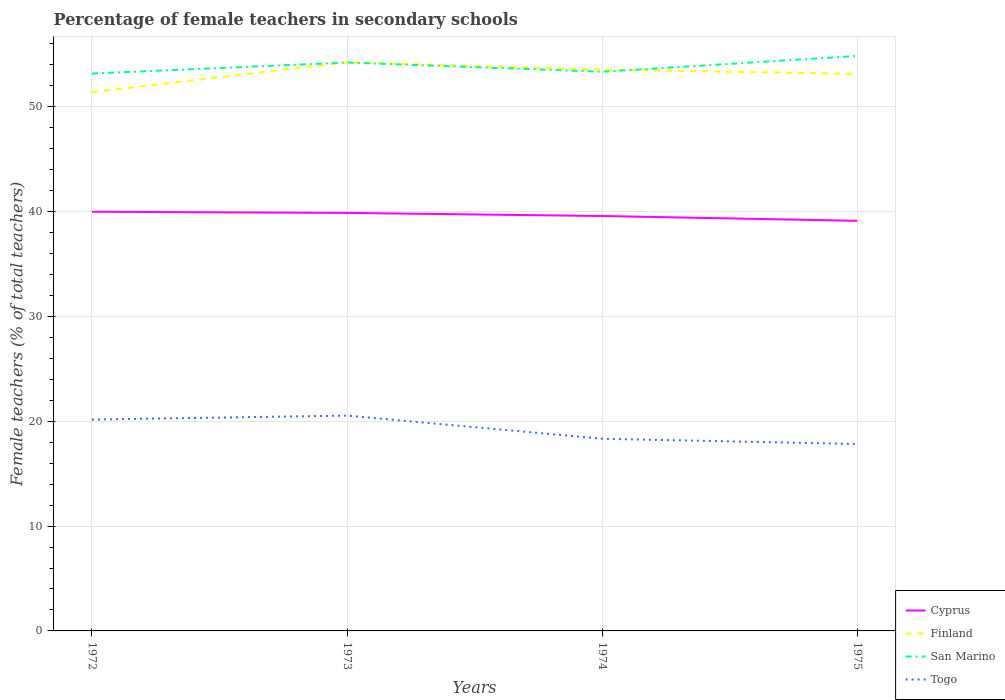How many different coloured lines are there?
Keep it short and to the point. 4. Does the line corresponding to Cyprus intersect with the line corresponding to Togo?
Your response must be concise. No. Is the number of lines equal to the number of legend labels?
Ensure brevity in your answer.  Yes. Across all years, what is the maximum percentage of female teachers in San Marino?
Offer a terse response. 53.16. In which year was the percentage of female teachers in Cyprus maximum?
Your answer should be compact. 1975. What is the total percentage of female teachers in Finland in the graph?
Your answer should be compact. -1.73. What is the difference between the highest and the second highest percentage of female teachers in Cyprus?
Offer a very short reply. 0.86. Is the percentage of female teachers in Cyprus strictly greater than the percentage of female teachers in Finland over the years?
Make the answer very short. Yes. What is the difference between two consecutive major ticks on the Y-axis?
Keep it short and to the point. 10. Are the values on the major ticks of Y-axis written in scientific E-notation?
Offer a very short reply. No. What is the title of the graph?
Your answer should be compact. Percentage of female teachers in secondary schools. Does "Eritrea" appear as one of the legend labels in the graph?
Offer a terse response. No. What is the label or title of the Y-axis?
Make the answer very short. Female teachers (% of total teachers). What is the Female teachers (% of total teachers) in Cyprus in 1972?
Give a very brief answer. 39.98. What is the Female teachers (% of total teachers) of Finland in 1972?
Make the answer very short. 51.4. What is the Female teachers (% of total teachers) in San Marino in 1972?
Your answer should be very brief. 53.16. What is the Female teachers (% of total teachers) of Togo in 1972?
Ensure brevity in your answer.  20.16. What is the Female teachers (% of total teachers) in Cyprus in 1973?
Offer a terse response. 39.87. What is the Female teachers (% of total teachers) in Finland in 1973?
Ensure brevity in your answer.  54.23. What is the Female teachers (% of total teachers) in San Marino in 1973?
Your answer should be very brief. 54.22. What is the Female teachers (% of total teachers) in Togo in 1973?
Your answer should be very brief. 20.54. What is the Female teachers (% of total teachers) in Cyprus in 1974?
Provide a short and direct response. 39.58. What is the Female teachers (% of total teachers) of Finland in 1974?
Provide a short and direct response. 53.55. What is the Female teachers (% of total teachers) in San Marino in 1974?
Your response must be concise. 53.33. What is the Female teachers (% of total teachers) of Togo in 1974?
Provide a short and direct response. 18.33. What is the Female teachers (% of total teachers) in Cyprus in 1975?
Make the answer very short. 39.12. What is the Female teachers (% of total teachers) in Finland in 1975?
Your answer should be compact. 53.13. What is the Female teachers (% of total teachers) in San Marino in 1975?
Keep it short and to the point. 54.84. What is the Female teachers (% of total teachers) in Togo in 1975?
Your answer should be very brief. 17.83. Across all years, what is the maximum Female teachers (% of total teachers) of Cyprus?
Ensure brevity in your answer.  39.98. Across all years, what is the maximum Female teachers (% of total teachers) in Finland?
Offer a very short reply. 54.23. Across all years, what is the maximum Female teachers (% of total teachers) in San Marino?
Your response must be concise. 54.84. Across all years, what is the maximum Female teachers (% of total teachers) of Togo?
Offer a terse response. 20.54. Across all years, what is the minimum Female teachers (% of total teachers) of Cyprus?
Offer a terse response. 39.12. Across all years, what is the minimum Female teachers (% of total teachers) in Finland?
Your response must be concise. 51.4. Across all years, what is the minimum Female teachers (% of total teachers) of San Marino?
Provide a succinct answer. 53.16. Across all years, what is the minimum Female teachers (% of total teachers) in Togo?
Offer a terse response. 17.83. What is the total Female teachers (% of total teachers) in Cyprus in the graph?
Your response must be concise. 158.54. What is the total Female teachers (% of total teachers) in Finland in the graph?
Your answer should be compact. 212.31. What is the total Female teachers (% of total teachers) of San Marino in the graph?
Make the answer very short. 215.55. What is the total Female teachers (% of total teachers) of Togo in the graph?
Ensure brevity in your answer.  76.86. What is the difference between the Female teachers (% of total teachers) in Cyprus in 1972 and that in 1973?
Make the answer very short. 0.11. What is the difference between the Female teachers (% of total teachers) in Finland in 1972 and that in 1973?
Provide a short and direct response. -2.84. What is the difference between the Female teachers (% of total teachers) in San Marino in 1972 and that in 1973?
Make the answer very short. -1.05. What is the difference between the Female teachers (% of total teachers) in Togo in 1972 and that in 1973?
Ensure brevity in your answer.  -0.38. What is the difference between the Female teachers (% of total teachers) of Cyprus in 1972 and that in 1974?
Offer a terse response. 0.41. What is the difference between the Female teachers (% of total teachers) in Finland in 1972 and that in 1974?
Your response must be concise. -2.15. What is the difference between the Female teachers (% of total teachers) of San Marino in 1972 and that in 1974?
Your answer should be compact. -0.17. What is the difference between the Female teachers (% of total teachers) of Togo in 1972 and that in 1974?
Keep it short and to the point. 1.83. What is the difference between the Female teachers (% of total teachers) in Cyprus in 1972 and that in 1975?
Provide a succinct answer. 0.86. What is the difference between the Female teachers (% of total teachers) of Finland in 1972 and that in 1975?
Give a very brief answer. -1.73. What is the difference between the Female teachers (% of total teachers) of San Marino in 1972 and that in 1975?
Keep it short and to the point. -1.67. What is the difference between the Female teachers (% of total teachers) of Togo in 1972 and that in 1975?
Keep it short and to the point. 2.33. What is the difference between the Female teachers (% of total teachers) of Cyprus in 1973 and that in 1974?
Make the answer very short. 0.3. What is the difference between the Female teachers (% of total teachers) of Finland in 1973 and that in 1974?
Offer a very short reply. 0.69. What is the difference between the Female teachers (% of total teachers) of San Marino in 1973 and that in 1974?
Provide a short and direct response. 0.88. What is the difference between the Female teachers (% of total teachers) of Togo in 1973 and that in 1974?
Keep it short and to the point. 2.21. What is the difference between the Female teachers (% of total teachers) of Cyprus in 1973 and that in 1975?
Offer a very short reply. 0.75. What is the difference between the Female teachers (% of total teachers) of Finland in 1973 and that in 1975?
Your answer should be very brief. 1.1. What is the difference between the Female teachers (% of total teachers) in San Marino in 1973 and that in 1975?
Your answer should be compact. -0.62. What is the difference between the Female teachers (% of total teachers) of Togo in 1973 and that in 1975?
Offer a very short reply. 2.71. What is the difference between the Female teachers (% of total teachers) in Cyprus in 1974 and that in 1975?
Provide a short and direct response. 0.46. What is the difference between the Female teachers (% of total teachers) of Finland in 1974 and that in 1975?
Offer a very short reply. 0.42. What is the difference between the Female teachers (% of total teachers) of San Marino in 1974 and that in 1975?
Your response must be concise. -1.51. What is the difference between the Female teachers (% of total teachers) of Togo in 1974 and that in 1975?
Provide a short and direct response. 0.5. What is the difference between the Female teachers (% of total teachers) in Cyprus in 1972 and the Female teachers (% of total teachers) in Finland in 1973?
Provide a short and direct response. -14.25. What is the difference between the Female teachers (% of total teachers) of Cyprus in 1972 and the Female teachers (% of total teachers) of San Marino in 1973?
Keep it short and to the point. -14.24. What is the difference between the Female teachers (% of total teachers) of Cyprus in 1972 and the Female teachers (% of total teachers) of Togo in 1973?
Give a very brief answer. 19.44. What is the difference between the Female teachers (% of total teachers) in Finland in 1972 and the Female teachers (% of total teachers) in San Marino in 1973?
Offer a terse response. -2.82. What is the difference between the Female teachers (% of total teachers) in Finland in 1972 and the Female teachers (% of total teachers) in Togo in 1973?
Provide a short and direct response. 30.86. What is the difference between the Female teachers (% of total teachers) of San Marino in 1972 and the Female teachers (% of total teachers) of Togo in 1973?
Ensure brevity in your answer.  32.63. What is the difference between the Female teachers (% of total teachers) of Cyprus in 1972 and the Female teachers (% of total teachers) of Finland in 1974?
Make the answer very short. -13.57. What is the difference between the Female teachers (% of total teachers) in Cyprus in 1972 and the Female teachers (% of total teachers) in San Marino in 1974?
Offer a very short reply. -13.35. What is the difference between the Female teachers (% of total teachers) of Cyprus in 1972 and the Female teachers (% of total teachers) of Togo in 1974?
Your answer should be very brief. 21.65. What is the difference between the Female teachers (% of total teachers) of Finland in 1972 and the Female teachers (% of total teachers) of San Marino in 1974?
Provide a succinct answer. -1.94. What is the difference between the Female teachers (% of total teachers) in Finland in 1972 and the Female teachers (% of total teachers) in Togo in 1974?
Offer a terse response. 33.07. What is the difference between the Female teachers (% of total teachers) in San Marino in 1972 and the Female teachers (% of total teachers) in Togo in 1974?
Your response must be concise. 34.83. What is the difference between the Female teachers (% of total teachers) of Cyprus in 1972 and the Female teachers (% of total teachers) of Finland in 1975?
Offer a very short reply. -13.15. What is the difference between the Female teachers (% of total teachers) in Cyprus in 1972 and the Female teachers (% of total teachers) in San Marino in 1975?
Provide a succinct answer. -14.86. What is the difference between the Female teachers (% of total teachers) in Cyprus in 1972 and the Female teachers (% of total teachers) in Togo in 1975?
Your answer should be very brief. 22.15. What is the difference between the Female teachers (% of total teachers) of Finland in 1972 and the Female teachers (% of total teachers) of San Marino in 1975?
Offer a very short reply. -3.44. What is the difference between the Female teachers (% of total teachers) of Finland in 1972 and the Female teachers (% of total teachers) of Togo in 1975?
Provide a short and direct response. 33.57. What is the difference between the Female teachers (% of total teachers) of San Marino in 1972 and the Female teachers (% of total teachers) of Togo in 1975?
Make the answer very short. 35.34. What is the difference between the Female teachers (% of total teachers) in Cyprus in 1973 and the Female teachers (% of total teachers) in Finland in 1974?
Provide a short and direct response. -13.68. What is the difference between the Female teachers (% of total teachers) in Cyprus in 1973 and the Female teachers (% of total teachers) in San Marino in 1974?
Make the answer very short. -13.46. What is the difference between the Female teachers (% of total teachers) of Cyprus in 1973 and the Female teachers (% of total teachers) of Togo in 1974?
Keep it short and to the point. 21.54. What is the difference between the Female teachers (% of total teachers) in Finland in 1973 and the Female teachers (% of total teachers) in San Marino in 1974?
Your answer should be compact. 0.9. What is the difference between the Female teachers (% of total teachers) in Finland in 1973 and the Female teachers (% of total teachers) in Togo in 1974?
Your answer should be compact. 35.9. What is the difference between the Female teachers (% of total teachers) in San Marino in 1973 and the Female teachers (% of total teachers) in Togo in 1974?
Provide a short and direct response. 35.89. What is the difference between the Female teachers (% of total teachers) of Cyprus in 1973 and the Female teachers (% of total teachers) of Finland in 1975?
Give a very brief answer. -13.26. What is the difference between the Female teachers (% of total teachers) in Cyprus in 1973 and the Female teachers (% of total teachers) in San Marino in 1975?
Provide a short and direct response. -14.97. What is the difference between the Female teachers (% of total teachers) of Cyprus in 1973 and the Female teachers (% of total teachers) of Togo in 1975?
Ensure brevity in your answer.  22.04. What is the difference between the Female teachers (% of total teachers) of Finland in 1973 and the Female teachers (% of total teachers) of San Marino in 1975?
Your answer should be compact. -0.6. What is the difference between the Female teachers (% of total teachers) of Finland in 1973 and the Female teachers (% of total teachers) of Togo in 1975?
Offer a very short reply. 36.41. What is the difference between the Female teachers (% of total teachers) of San Marino in 1973 and the Female teachers (% of total teachers) of Togo in 1975?
Provide a succinct answer. 36.39. What is the difference between the Female teachers (% of total teachers) of Cyprus in 1974 and the Female teachers (% of total teachers) of Finland in 1975?
Provide a succinct answer. -13.55. What is the difference between the Female teachers (% of total teachers) of Cyprus in 1974 and the Female teachers (% of total teachers) of San Marino in 1975?
Provide a short and direct response. -15.26. What is the difference between the Female teachers (% of total teachers) in Cyprus in 1974 and the Female teachers (% of total teachers) in Togo in 1975?
Your answer should be compact. 21.75. What is the difference between the Female teachers (% of total teachers) of Finland in 1974 and the Female teachers (% of total teachers) of San Marino in 1975?
Your response must be concise. -1.29. What is the difference between the Female teachers (% of total teachers) of Finland in 1974 and the Female teachers (% of total teachers) of Togo in 1975?
Keep it short and to the point. 35.72. What is the difference between the Female teachers (% of total teachers) in San Marino in 1974 and the Female teachers (% of total teachers) in Togo in 1975?
Offer a very short reply. 35.51. What is the average Female teachers (% of total teachers) of Cyprus per year?
Keep it short and to the point. 39.64. What is the average Female teachers (% of total teachers) of Finland per year?
Give a very brief answer. 53.08. What is the average Female teachers (% of total teachers) in San Marino per year?
Provide a short and direct response. 53.89. What is the average Female teachers (% of total teachers) in Togo per year?
Your answer should be compact. 19.21. In the year 1972, what is the difference between the Female teachers (% of total teachers) of Cyprus and Female teachers (% of total teachers) of Finland?
Provide a succinct answer. -11.41. In the year 1972, what is the difference between the Female teachers (% of total teachers) in Cyprus and Female teachers (% of total teachers) in San Marino?
Make the answer very short. -13.18. In the year 1972, what is the difference between the Female teachers (% of total teachers) of Cyprus and Female teachers (% of total teachers) of Togo?
Ensure brevity in your answer.  19.82. In the year 1972, what is the difference between the Female teachers (% of total teachers) of Finland and Female teachers (% of total teachers) of San Marino?
Provide a short and direct response. -1.77. In the year 1972, what is the difference between the Female teachers (% of total teachers) in Finland and Female teachers (% of total teachers) in Togo?
Your answer should be very brief. 31.24. In the year 1972, what is the difference between the Female teachers (% of total teachers) in San Marino and Female teachers (% of total teachers) in Togo?
Provide a short and direct response. 33. In the year 1973, what is the difference between the Female teachers (% of total teachers) in Cyprus and Female teachers (% of total teachers) in Finland?
Give a very brief answer. -14.36. In the year 1973, what is the difference between the Female teachers (% of total teachers) in Cyprus and Female teachers (% of total teachers) in San Marino?
Keep it short and to the point. -14.35. In the year 1973, what is the difference between the Female teachers (% of total teachers) in Cyprus and Female teachers (% of total teachers) in Togo?
Provide a short and direct response. 19.33. In the year 1973, what is the difference between the Female teachers (% of total teachers) of Finland and Female teachers (% of total teachers) of San Marino?
Your response must be concise. 0.02. In the year 1973, what is the difference between the Female teachers (% of total teachers) of Finland and Female teachers (% of total teachers) of Togo?
Provide a succinct answer. 33.7. In the year 1973, what is the difference between the Female teachers (% of total teachers) in San Marino and Female teachers (% of total teachers) in Togo?
Your response must be concise. 33.68. In the year 1974, what is the difference between the Female teachers (% of total teachers) of Cyprus and Female teachers (% of total teachers) of Finland?
Your answer should be very brief. -13.97. In the year 1974, what is the difference between the Female teachers (% of total teachers) in Cyprus and Female teachers (% of total teachers) in San Marino?
Provide a succinct answer. -13.76. In the year 1974, what is the difference between the Female teachers (% of total teachers) in Cyprus and Female teachers (% of total teachers) in Togo?
Keep it short and to the point. 21.24. In the year 1974, what is the difference between the Female teachers (% of total teachers) in Finland and Female teachers (% of total teachers) in San Marino?
Make the answer very short. 0.21. In the year 1974, what is the difference between the Female teachers (% of total teachers) of Finland and Female teachers (% of total teachers) of Togo?
Offer a very short reply. 35.22. In the year 1974, what is the difference between the Female teachers (% of total teachers) in San Marino and Female teachers (% of total teachers) in Togo?
Offer a very short reply. 35. In the year 1975, what is the difference between the Female teachers (% of total teachers) in Cyprus and Female teachers (% of total teachers) in Finland?
Ensure brevity in your answer.  -14.01. In the year 1975, what is the difference between the Female teachers (% of total teachers) of Cyprus and Female teachers (% of total teachers) of San Marino?
Ensure brevity in your answer.  -15.72. In the year 1975, what is the difference between the Female teachers (% of total teachers) of Cyprus and Female teachers (% of total teachers) of Togo?
Offer a terse response. 21.29. In the year 1975, what is the difference between the Female teachers (% of total teachers) in Finland and Female teachers (% of total teachers) in San Marino?
Ensure brevity in your answer.  -1.71. In the year 1975, what is the difference between the Female teachers (% of total teachers) of Finland and Female teachers (% of total teachers) of Togo?
Provide a short and direct response. 35.3. In the year 1975, what is the difference between the Female teachers (% of total teachers) of San Marino and Female teachers (% of total teachers) of Togo?
Offer a terse response. 37.01. What is the ratio of the Female teachers (% of total teachers) in Cyprus in 1972 to that in 1973?
Offer a terse response. 1. What is the ratio of the Female teachers (% of total teachers) of Finland in 1972 to that in 1973?
Your response must be concise. 0.95. What is the ratio of the Female teachers (% of total teachers) in San Marino in 1972 to that in 1973?
Offer a terse response. 0.98. What is the ratio of the Female teachers (% of total teachers) of Togo in 1972 to that in 1973?
Offer a terse response. 0.98. What is the ratio of the Female teachers (% of total teachers) in Cyprus in 1972 to that in 1974?
Give a very brief answer. 1.01. What is the ratio of the Female teachers (% of total teachers) in Finland in 1972 to that in 1974?
Provide a succinct answer. 0.96. What is the ratio of the Female teachers (% of total teachers) in Togo in 1972 to that in 1974?
Provide a short and direct response. 1.1. What is the ratio of the Female teachers (% of total teachers) of Cyprus in 1972 to that in 1975?
Provide a short and direct response. 1.02. What is the ratio of the Female teachers (% of total teachers) of Finland in 1972 to that in 1975?
Make the answer very short. 0.97. What is the ratio of the Female teachers (% of total teachers) of San Marino in 1972 to that in 1975?
Keep it short and to the point. 0.97. What is the ratio of the Female teachers (% of total teachers) in Togo in 1972 to that in 1975?
Provide a succinct answer. 1.13. What is the ratio of the Female teachers (% of total teachers) in Cyprus in 1973 to that in 1974?
Ensure brevity in your answer.  1.01. What is the ratio of the Female teachers (% of total teachers) in Finland in 1973 to that in 1974?
Ensure brevity in your answer.  1.01. What is the ratio of the Female teachers (% of total teachers) in San Marino in 1973 to that in 1974?
Your response must be concise. 1.02. What is the ratio of the Female teachers (% of total teachers) of Togo in 1973 to that in 1974?
Your answer should be compact. 1.12. What is the ratio of the Female teachers (% of total teachers) of Cyprus in 1973 to that in 1975?
Give a very brief answer. 1.02. What is the ratio of the Female teachers (% of total teachers) in Finland in 1973 to that in 1975?
Your answer should be very brief. 1.02. What is the ratio of the Female teachers (% of total teachers) in San Marino in 1973 to that in 1975?
Your answer should be compact. 0.99. What is the ratio of the Female teachers (% of total teachers) of Togo in 1973 to that in 1975?
Ensure brevity in your answer.  1.15. What is the ratio of the Female teachers (% of total teachers) of Cyprus in 1974 to that in 1975?
Offer a very short reply. 1.01. What is the ratio of the Female teachers (% of total teachers) of Finland in 1974 to that in 1975?
Provide a short and direct response. 1.01. What is the ratio of the Female teachers (% of total teachers) in San Marino in 1974 to that in 1975?
Provide a succinct answer. 0.97. What is the ratio of the Female teachers (% of total teachers) of Togo in 1974 to that in 1975?
Provide a succinct answer. 1.03. What is the difference between the highest and the second highest Female teachers (% of total teachers) in Cyprus?
Give a very brief answer. 0.11. What is the difference between the highest and the second highest Female teachers (% of total teachers) of Finland?
Your answer should be very brief. 0.69. What is the difference between the highest and the second highest Female teachers (% of total teachers) in San Marino?
Offer a terse response. 0.62. What is the difference between the highest and the second highest Female teachers (% of total teachers) in Togo?
Give a very brief answer. 0.38. What is the difference between the highest and the lowest Female teachers (% of total teachers) of Cyprus?
Keep it short and to the point. 0.86. What is the difference between the highest and the lowest Female teachers (% of total teachers) in Finland?
Your response must be concise. 2.84. What is the difference between the highest and the lowest Female teachers (% of total teachers) of San Marino?
Your answer should be compact. 1.67. What is the difference between the highest and the lowest Female teachers (% of total teachers) in Togo?
Offer a terse response. 2.71. 